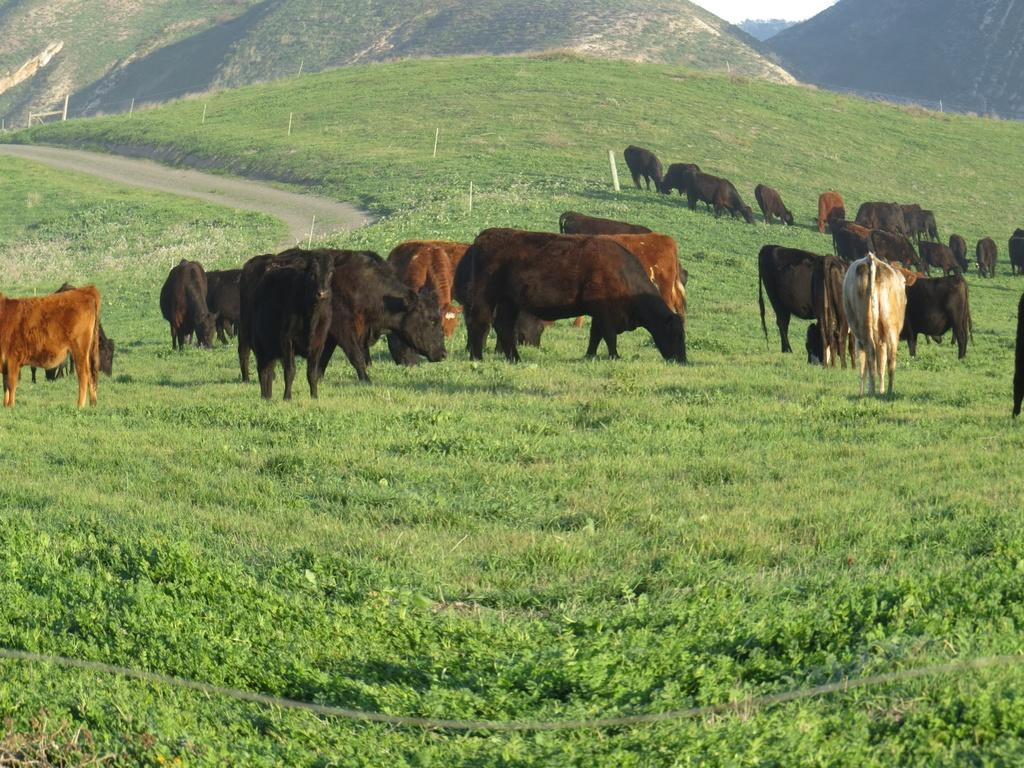What type of animal is in the image? There is a cattle in the image. What is the cattle doing in the image? The cattle is grazing the grass. What can be seen in the distance in the image? There are mountains visible in the background of the image. What type of feather can be seen on the cattle in the image? There are no feathers present on the cattle in the image, as cattle are mammals and do not have feathers. 